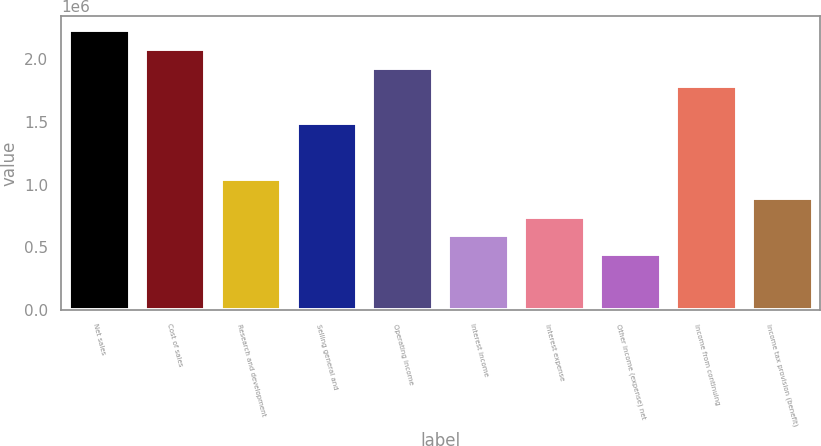<chart> <loc_0><loc_0><loc_500><loc_500><bar_chart><fcel>Net sales<fcel>Cost of sales<fcel>Research and development<fcel>Selling general and<fcel>Operating income<fcel>Interest income<fcel>Interest expense<fcel>Other income (expense) net<fcel>Income from continuing<fcel>Income tax provision (benefit)<nl><fcel>2.23081e+06<fcel>2.08209e+06<fcel>1.04104e+06<fcel>1.4872e+06<fcel>1.93337e+06<fcel>594883<fcel>743603<fcel>446162<fcel>1.78465e+06<fcel>892324<nl></chart> 